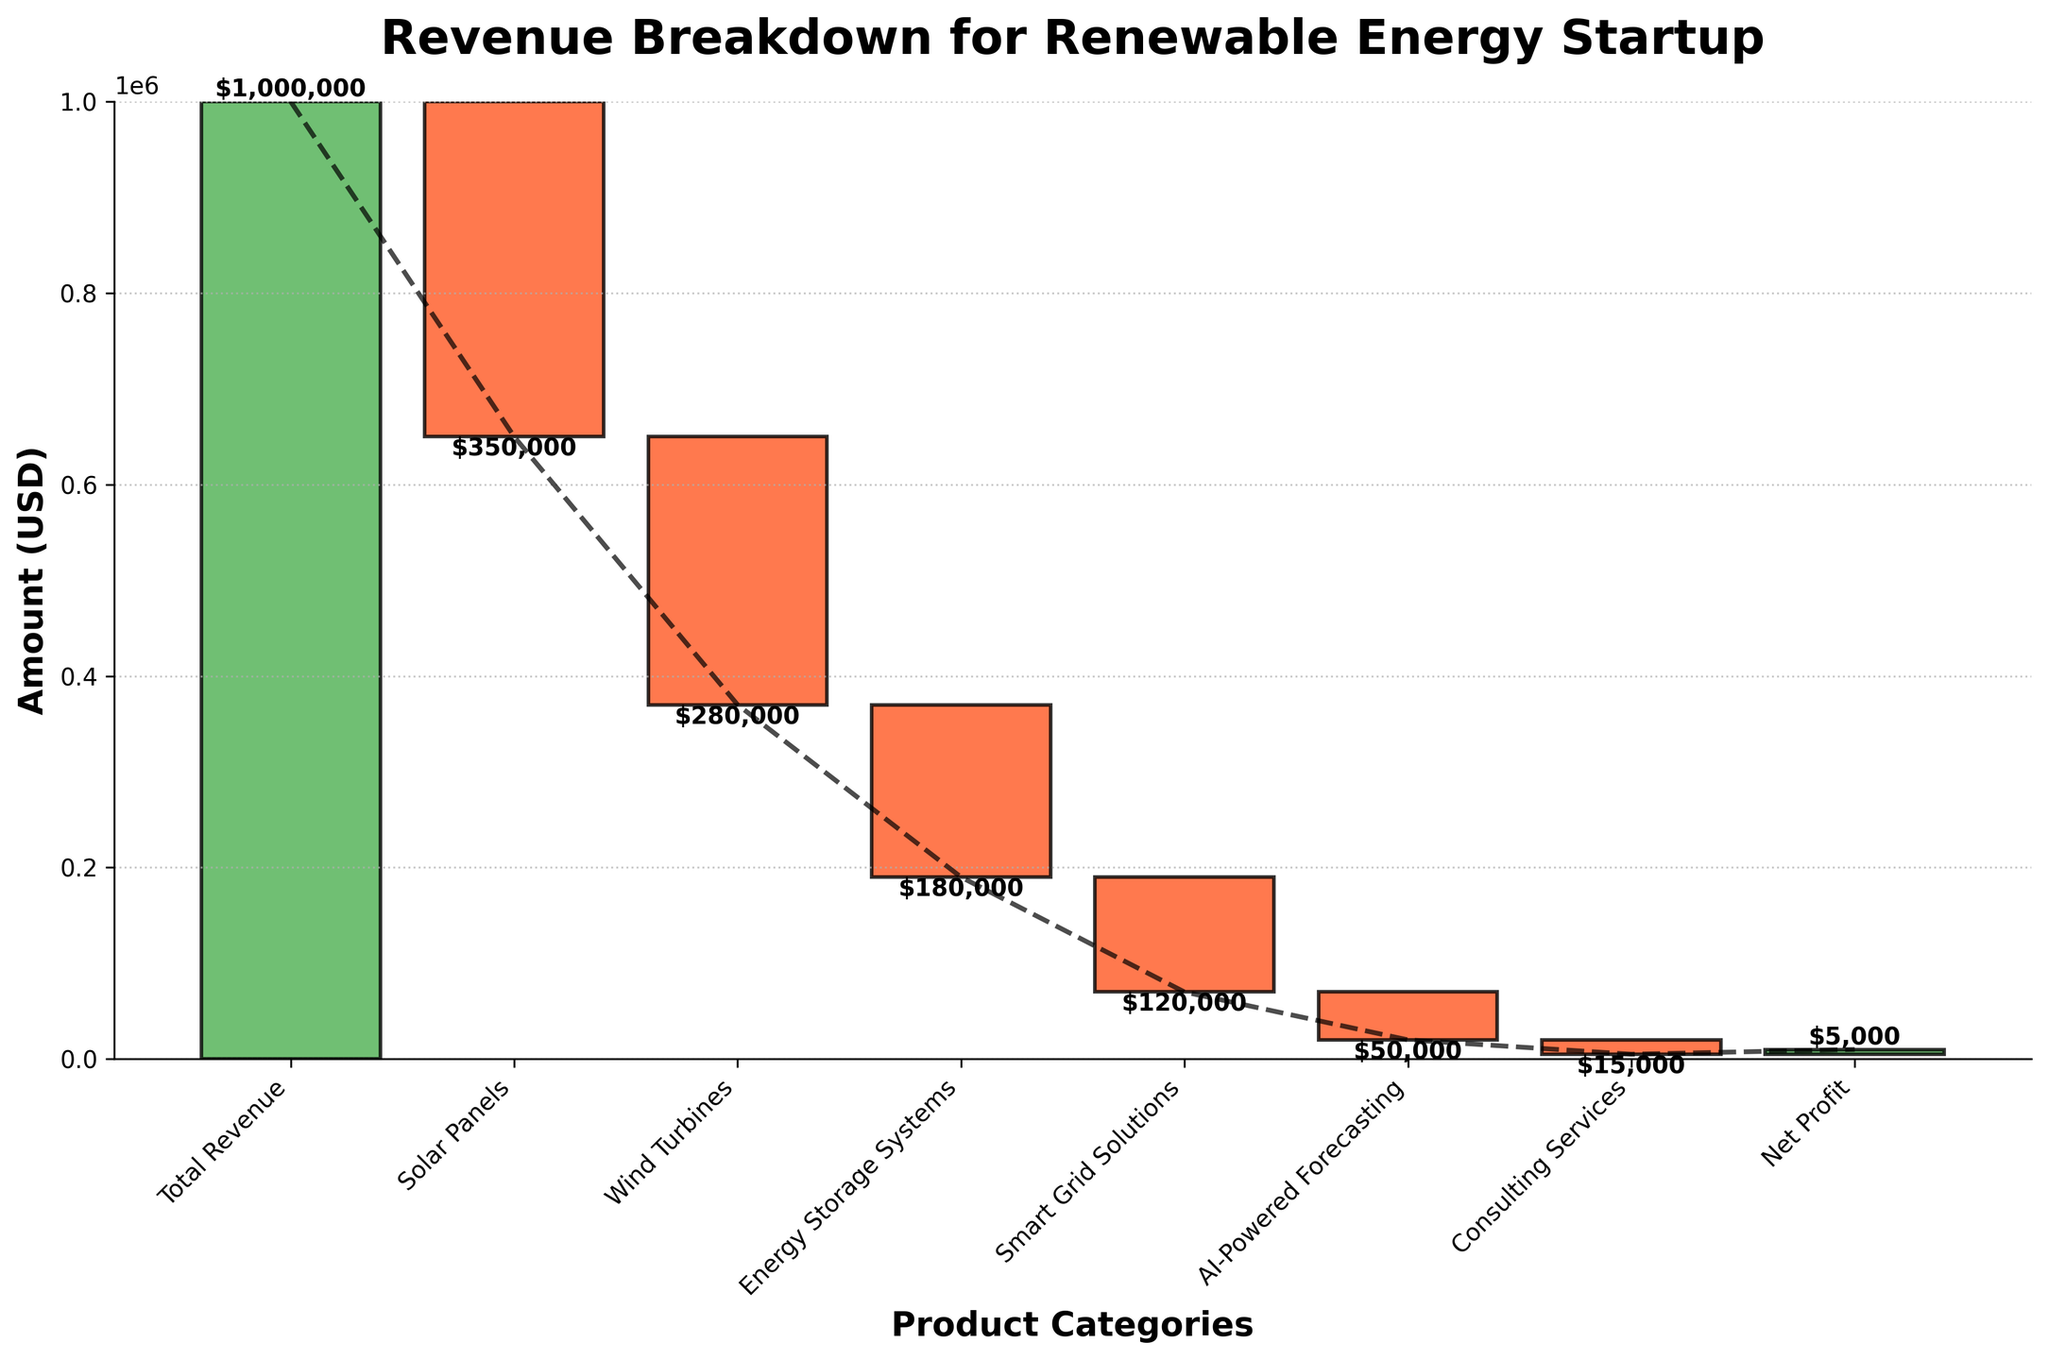What is the total revenue for the renewable energy startup? The total revenue is shown as the first bar in the chart labeled "Total Revenue".
Answer: $1,000,000 How much revenue comes from Solar Panels? The bar labeled "Solar Panels" shows the revenue deduction from Solar Panels.
Answer: -$350,000 What is the final net profit for the renewable energy startup? The final bar labeled "Net Profit" at the end of the chart represents the net profit.
Answer: $5,000 Which product category results in the largest revenue deduction? By comparing the negative amounts associated with each product category, "Solar Panels" has the largest deduction of -$350,000.
Answer: Solar Panels What cumulative value is there after accounting for Energy Storage Systems? Start at the total revenue and sequentially subtract the values until the Energy Storage Systems category: $1,000,000 - $350,000 (Solar Panels) - $280,000 (Wind Turbines) - $180,000 (Energy Storage Systems).
Answer: $190,000 How does the revenue from Wind Turbines compare to Energy Storage Systems? Wind Turbines result in a revenue deduction of -$280,000, whereas Energy Storage Systems result in -$180,000. Wind Turbines have a higher deduction.
Answer: Wind Turbines have a higher deduction What is the total revenue deduction from all product categories, excluding Consulting Services? Add all the values of product categories excluding Consulting Services: -$350,000 (Solar Panels) - $280,000 (Wind Turbines) - $180,000 (Energy Storage Systems) - $120,000 (Smart Grid Solutions) - $50,000 (AI-Powered Forecasting).
Answer: -$980,000 What percentage of the total revenue is deducted by Smart Grid Solutions? The deduction by Smart Grid Solutions is -$120,000. Divide by the total revenue and multiply by 100: (-$120,000 / $1,000,000) * 100%.
Answer: 12% How does the color scheme help identify the different segments in the chart? The chart uses color coding: green for total revenue and net profit, orange for negative values, and blue for positive values. This visually distinguishes these categories.
Answer: Color coding of green, orange, and blue Which product categories contribute to the positive cumulative flow in the chart? Only the "Total Revenue" at the start and the "Net Profit" at the end are green, indicating positive contributions. All others have negative values and are orange.
Answer: Total Revenue and Net Profit 